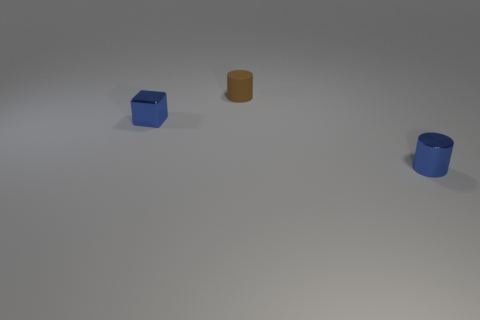Add 2 big cyan matte balls. How many objects exist? 5 Subtract all cylinders. How many objects are left? 1 Subtract all blocks. Subtract all metallic cubes. How many objects are left? 1 Add 1 brown rubber objects. How many brown rubber objects are left? 2 Add 3 metal cylinders. How many metal cylinders exist? 4 Subtract 0 yellow balls. How many objects are left? 3 